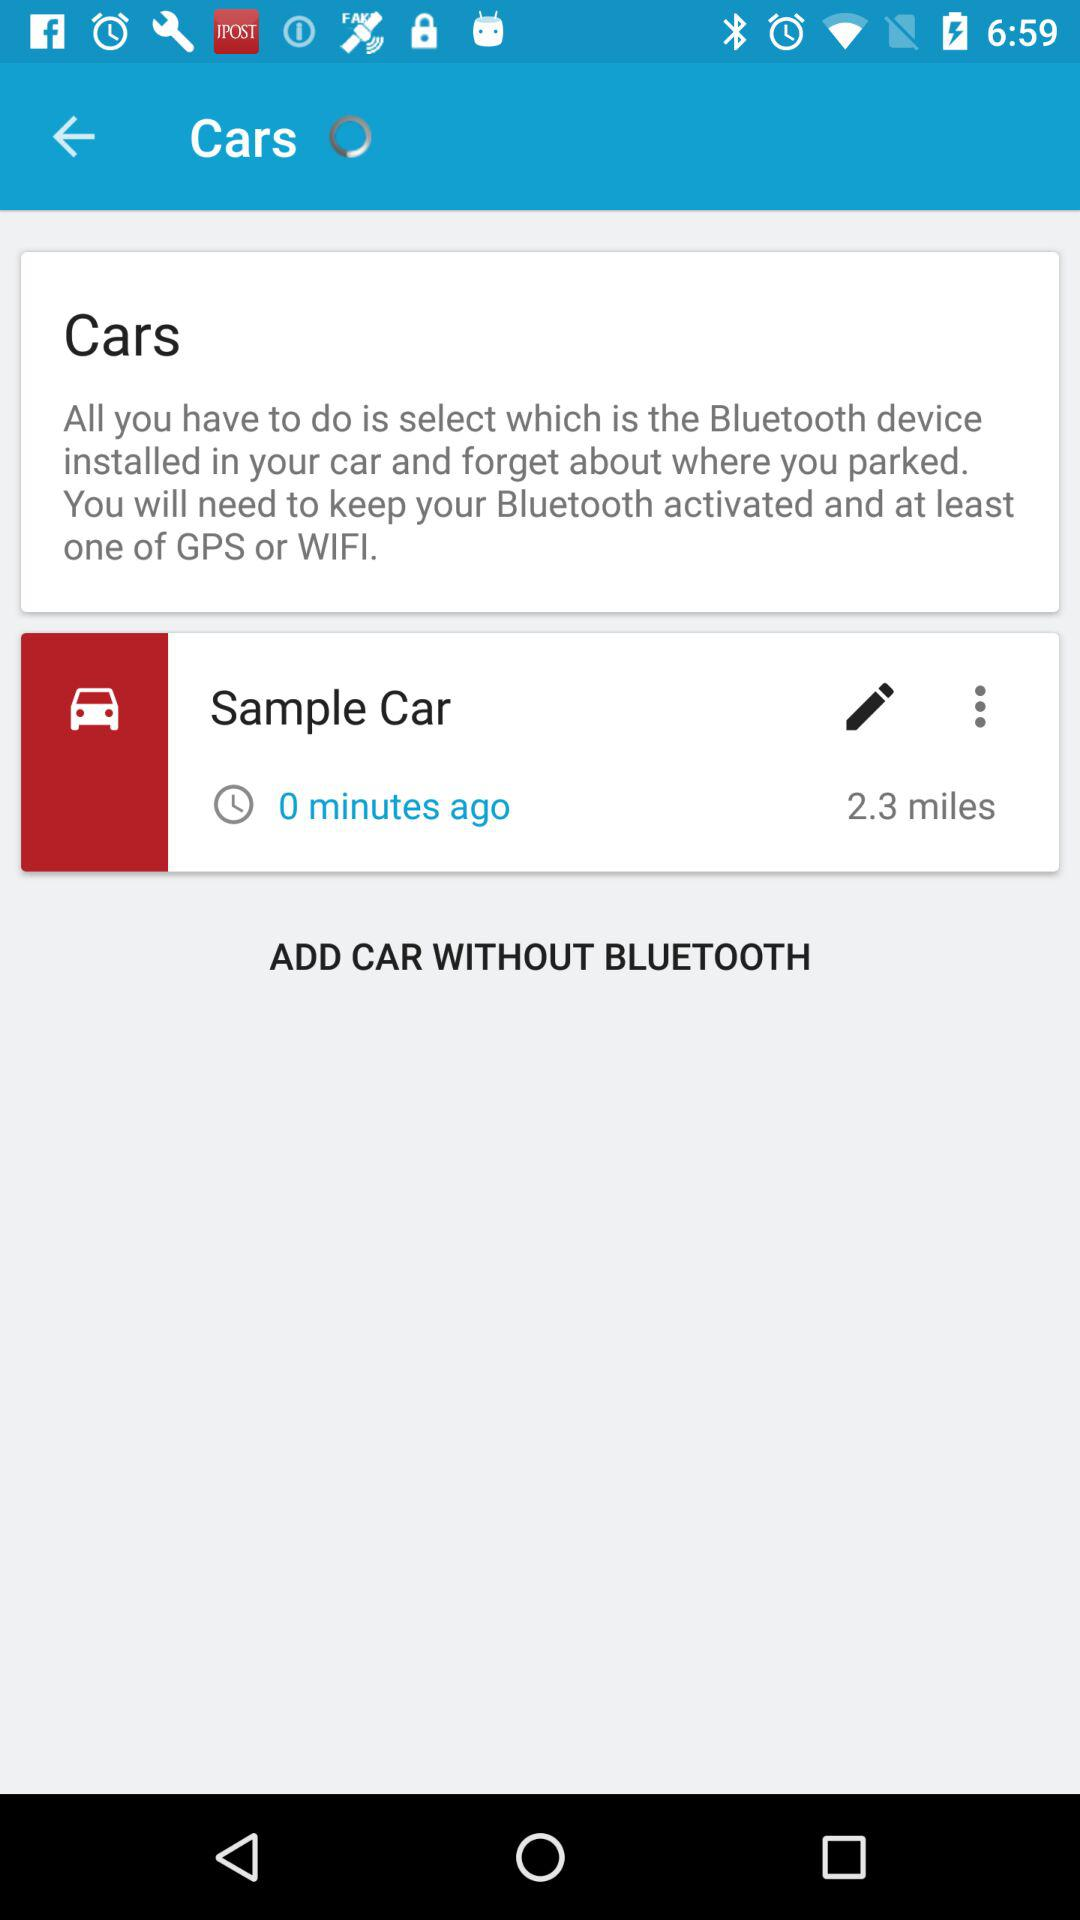How long ago Bluetooth activated in Sample car?
When the provided information is insufficient, respond with <no answer>. <no answer> 